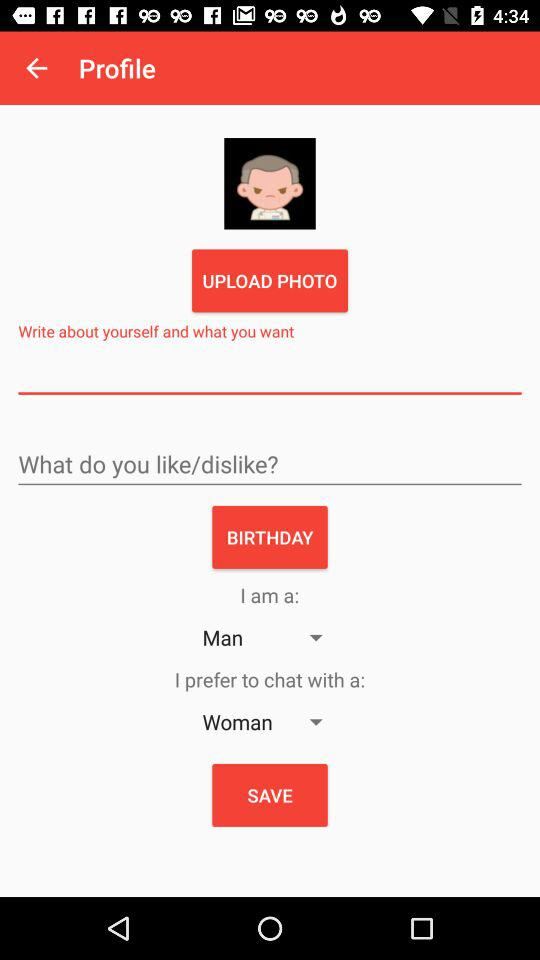What is the gender of the user? The gender of the user is "Man". 